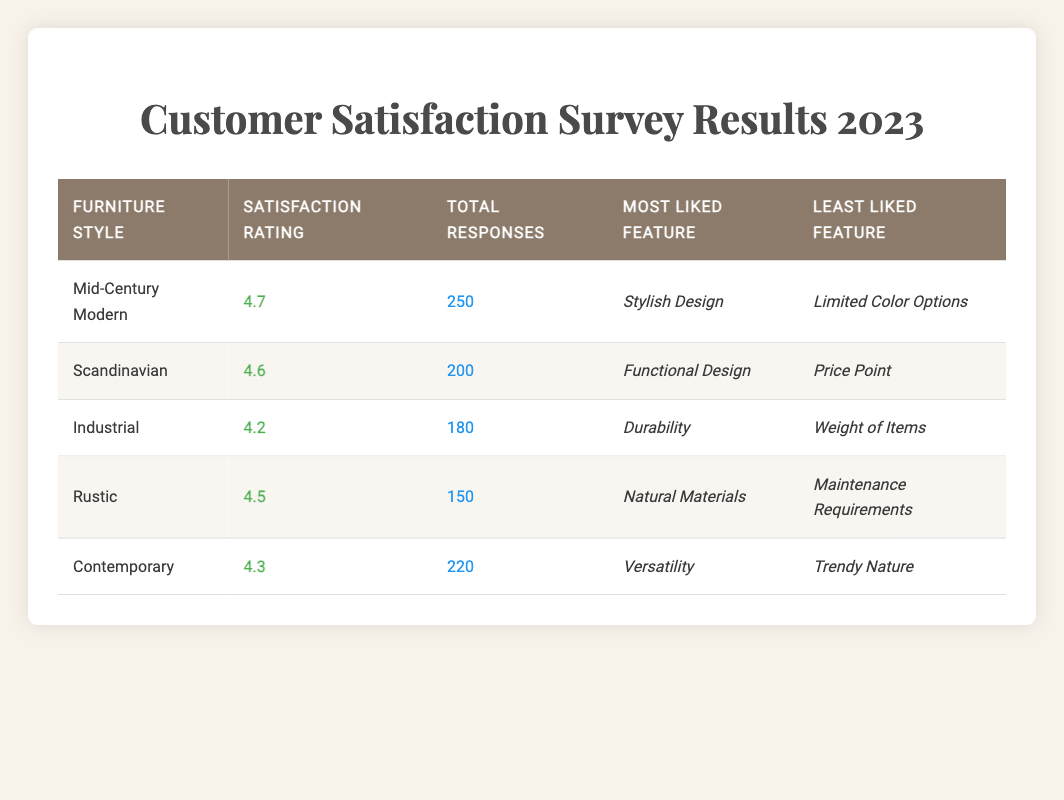What is the satisfaction rating for Mid-Century Modern furniture? The table lists the satisfaction rating for Mid-Century Modern as 4.7.
Answer: 4.7 How many total responses were collected for the Scandinavian furniture style? The table shows that there were 200 total responses for Scandinavian furniture.
Answer: 200 Which furniture style has the least liked feature related to price? Looking at the table, Scandinavian has the least liked feature of "Price Point."
Answer: Scandinavian What is the average satisfaction rating of all furniture styles listed? The satisfaction ratings are 4.7, 4.6, 4.2, 4.5, and 4.3. The sum is 22.3, and there are 5 styles, so the average is 22.3 / 5 = 4.46.
Answer: 4.46 Is there a furniture style that received a satisfaction rating higher than 4.5? Yes, Mid-Century Modern (4.7) and Scandinavian (4.6) both have ratings higher than 4.5.
Answer: Yes Which furniture style received the most total responses and what is that number? The table indicates that Mid-Century Modern received the most responses, totaling 250.
Answer: 250 What is the most liked feature for the Industrial furniture style? According to the table, the most liked feature for Industrial furniture is "Durability."
Answer: Durability Which furniture style received the lowest satisfaction rating, and what is that rating? The Industrial furniture style has the lowest satisfaction rating at 4.2 according to the table.
Answer: 4.2 Between Rustic and Contemporary styles, which one has a higher satisfaction rating and by how much? Rustic has a satisfaction rating of 4.5, while Contemporary has 4.3. The difference is 4.5 - 4.3 = 0.2.
Answer: 0.2 What do customers likely find least favorable about Contemporary furniture? The least liked feature for Contemporary furniture is noted as "Trendy Nature."
Answer: Trendy Nature 